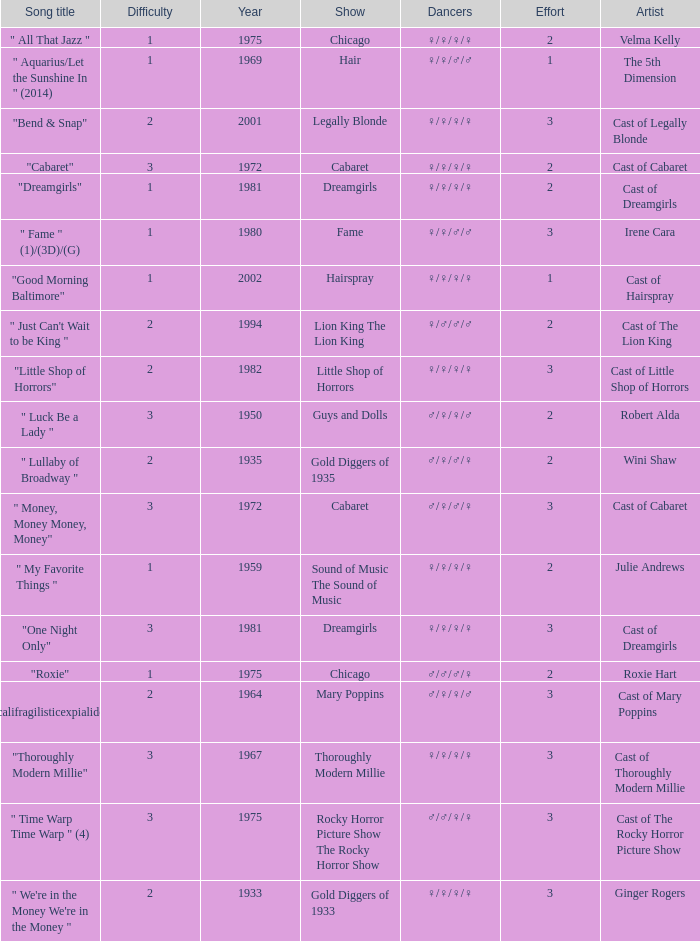How many shows were in 1994? 1.0. 